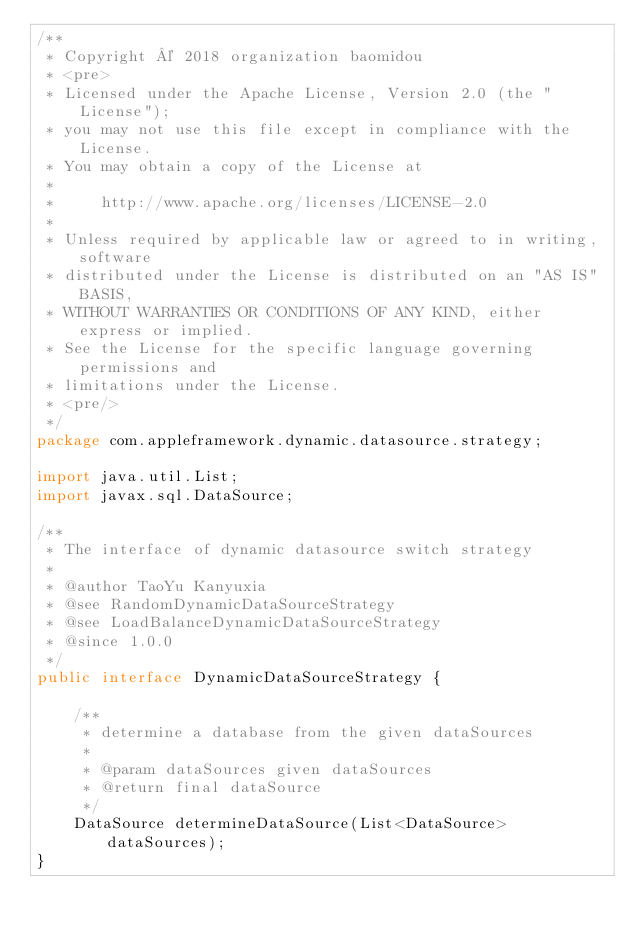<code> <loc_0><loc_0><loc_500><loc_500><_Java_>/**
 * Copyright © 2018 organization baomidou
 * <pre>
 * Licensed under the Apache License, Version 2.0 (the "License");
 * you may not use this file except in compliance with the License.
 * You may obtain a copy of the License at
 *
 *     http://www.apache.org/licenses/LICENSE-2.0
 *
 * Unless required by applicable law or agreed to in writing, software
 * distributed under the License is distributed on an "AS IS" BASIS,
 * WITHOUT WARRANTIES OR CONDITIONS OF ANY KIND, either express or implied.
 * See the License for the specific language governing permissions and
 * limitations under the License.
 * <pre/>
 */
package com.appleframework.dynamic.datasource.strategy;

import java.util.List;
import javax.sql.DataSource;

/**
 * The interface of dynamic datasource switch strategy
 *
 * @author TaoYu Kanyuxia
 * @see RandomDynamicDataSourceStrategy
 * @see LoadBalanceDynamicDataSourceStrategy
 * @since 1.0.0
 */
public interface DynamicDataSourceStrategy {

	/**
	 * determine a database from the given dataSources
	 *
	 * @param dataSources given dataSources
	 * @return final dataSource
	 */
	DataSource determineDataSource(List<DataSource> dataSources);
}
</code> 